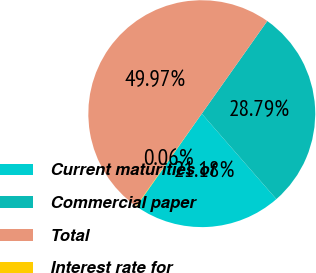<chart> <loc_0><loc_0><loc_500><loc_500><pie_chart><fcel>Current maturities of<fcel>Commercial paper<fcel>Total<fcel>Interest rate for<nl><fcel>21.18%<fcel>28.79%<fcel>49.97%<fcel>0.06%<nl></chart> 